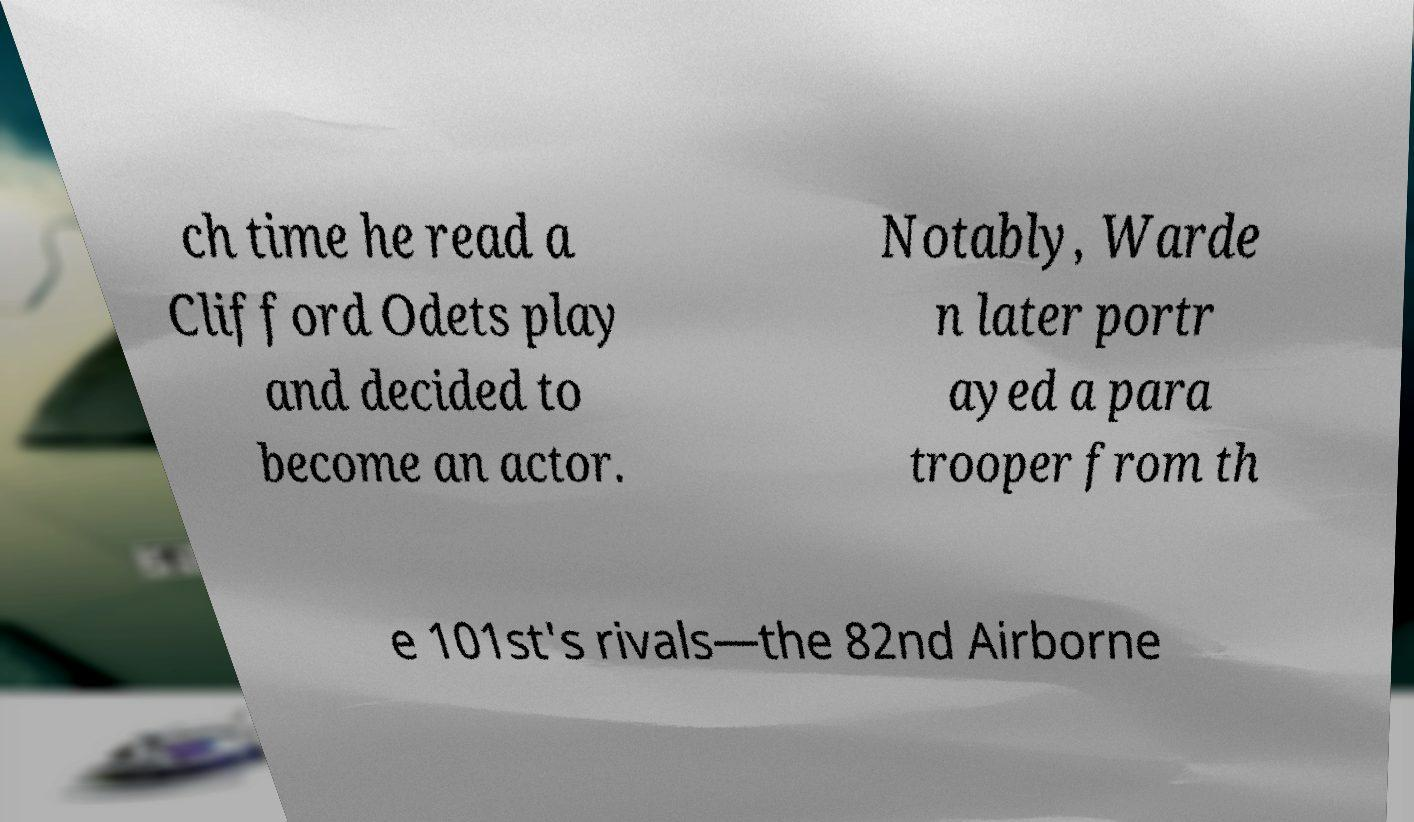Could you assist in decoding the text presented in this image and type it out clearly? ch time he read a Clifford Odets play and decided to become an actor. Notably, Warde n later portr ayed a para trooper from th e 101st's rivals—the 82nd Airborne 